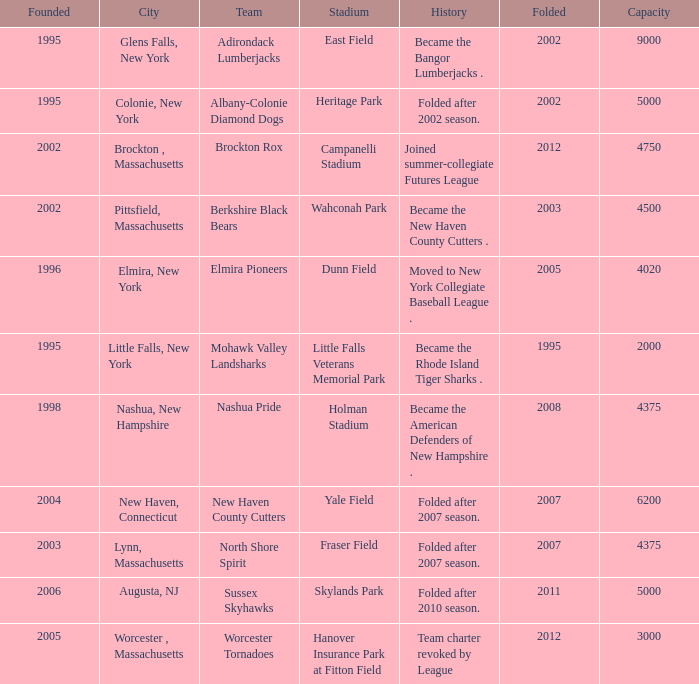What is the maximum founded year of the Worcester Tornadoes? 2005.0. 